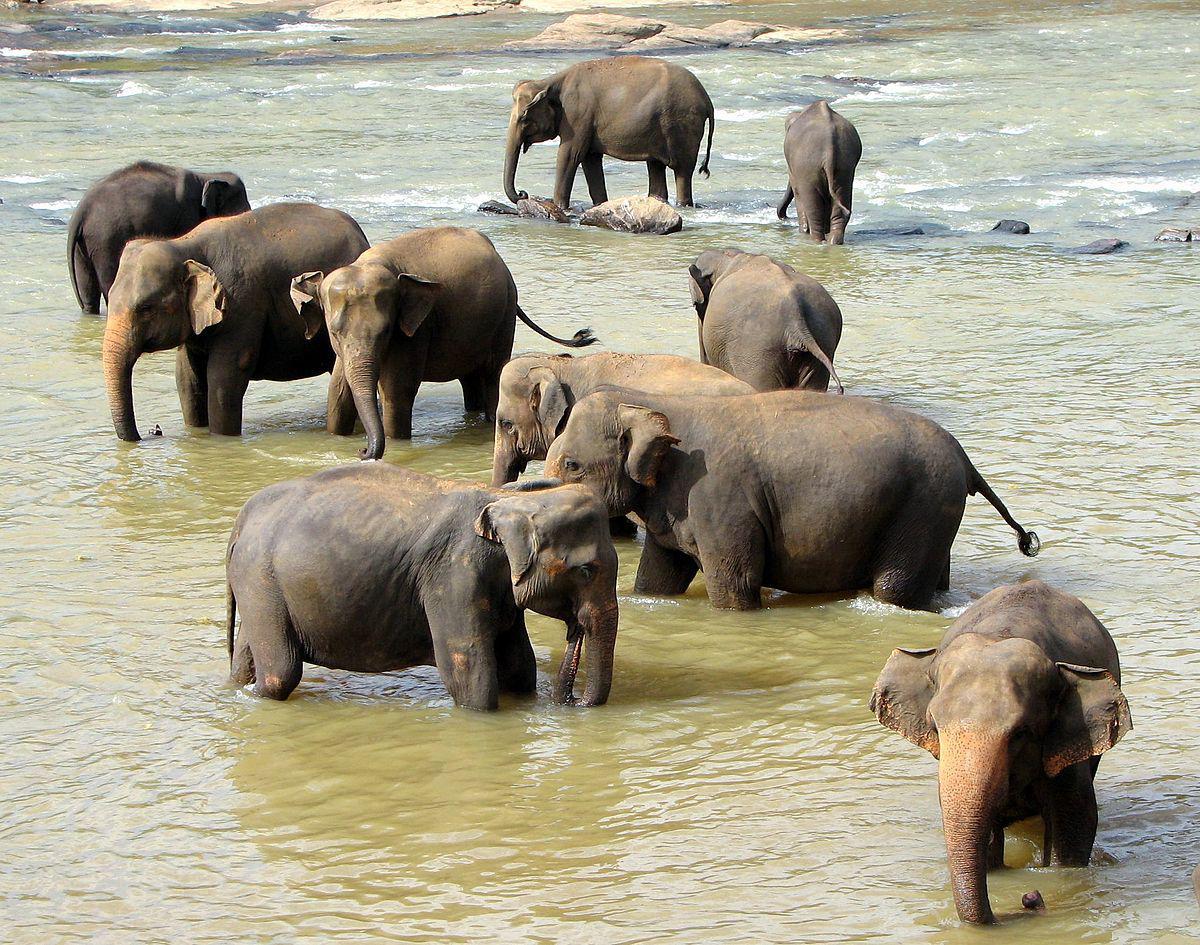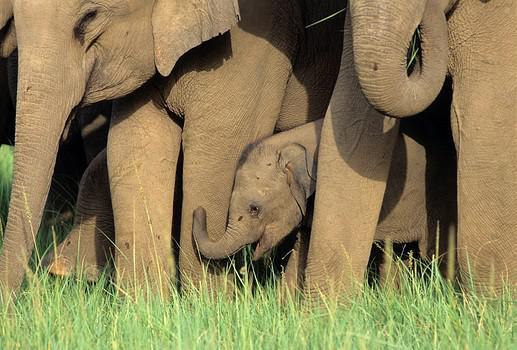The first image is the image on the left, the second image is the image on the right. For the images displayed, is the sentence "One image shows one gray baby elephant walking with no more than three adults." factually correct? Answer yes or no. No. The first image is the image on the left, the second image is the image on the right. For the images displayed, is the sentence "All elephants are headed in the same direction." factually correct? Answer yes or no. No. 